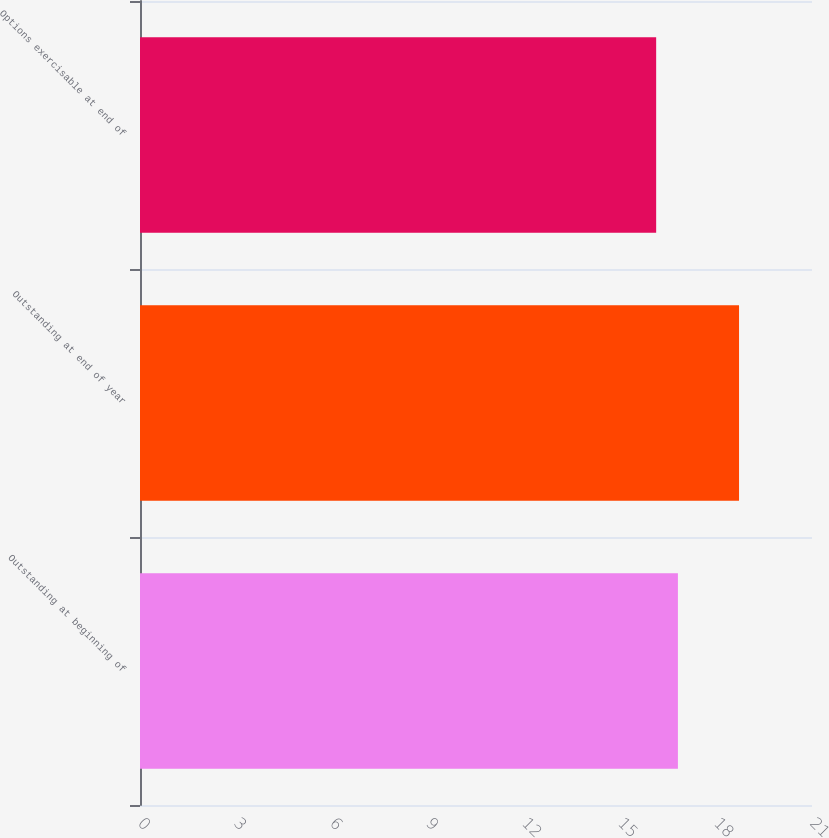Convert chart. <chart><loc_0><loc_0><loc_500><loc_500><bar_chart><fcel>Outstanding at beginning of<fcel>Outstanding at end of year<fcel>Options exercisable at end of<nl><fcel>16.81<fcel>18.72<fcel>16.13<nl></chart> 